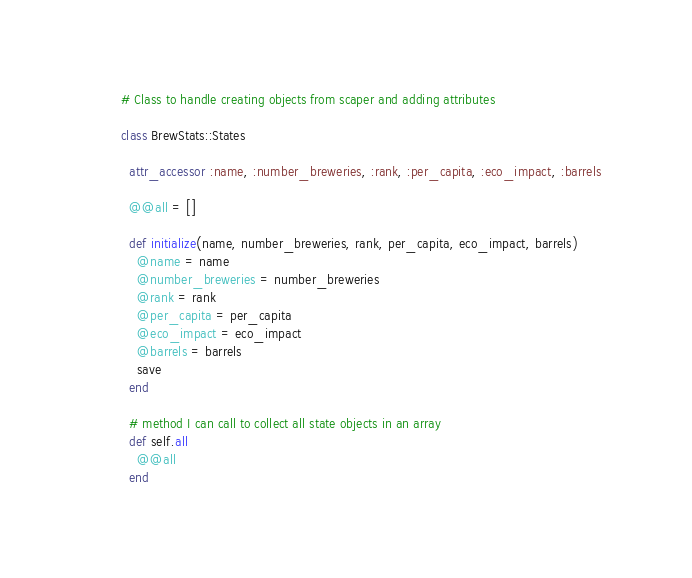Convert code to text. <code><loc_0><loc_0><loc_500><loc_500><_Ruby_># Class to handle creating objects from scaper and adding attributes

class BrewStats::States

  attr_accessor :name, :number_breweries, :rank, :per_capita, :eco_impact, :barrels

  @@all = []

  def initialize(name, number_breweries, rank, per_capita, eco_impact, barrels)
    @name = name
    @number_breweries = number_breweries
    @rank = rank
    @per_capita = per_capita
    @eco_impact = eco_impact
    @barrels = barrels
    save
  end

  # method I can call to collect all state objects in an array
  def self.all
    @@all
  end
</code> 